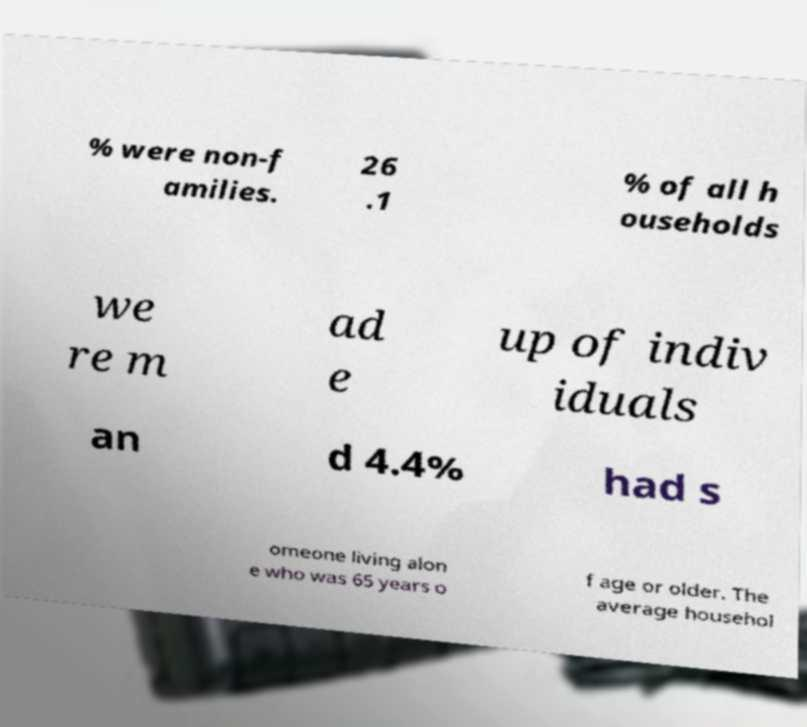Can you read and provide the text displayed in the image?This photo seems to have some interesting text. Can you extract and type it out for me? % were non-f amilies. 26 .1 % of all h ouseholds we re m ad e up of indiv iduals an d 4.4% had s omeone living alon e who was 65 years o f age or older. The average househol 